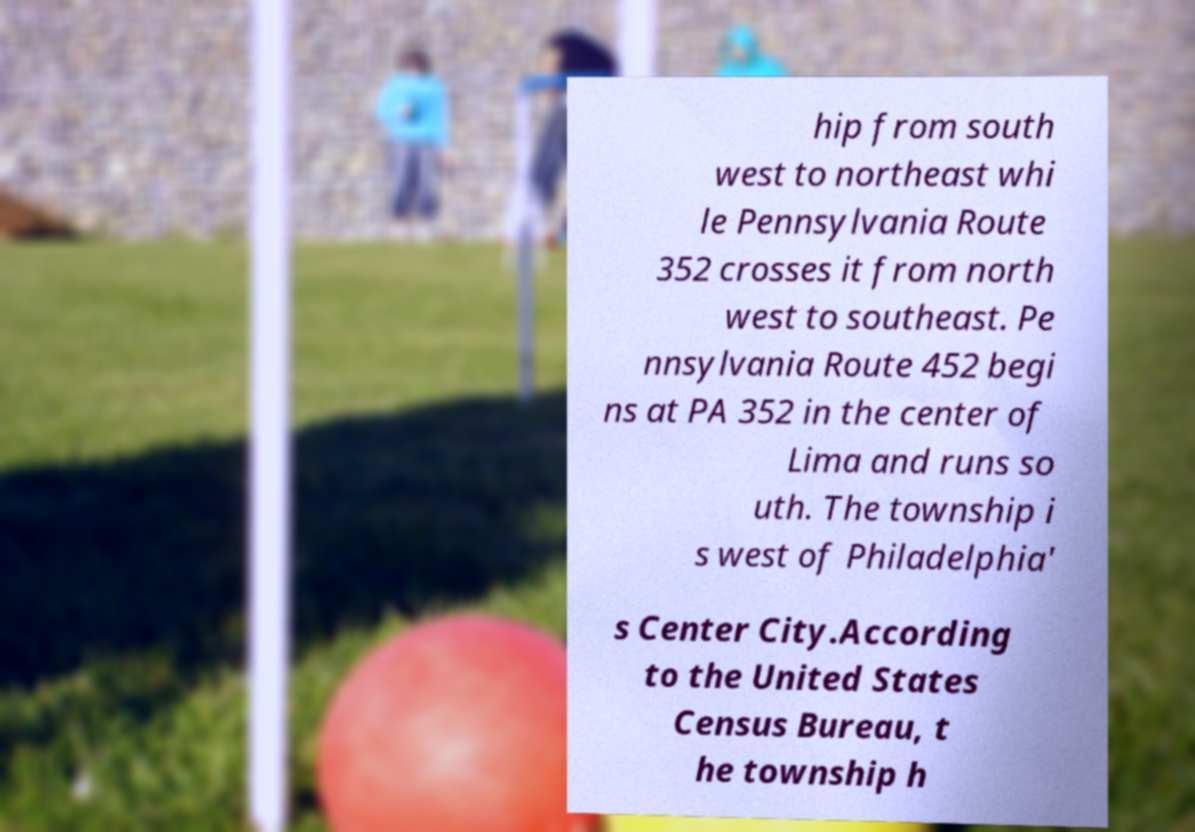I need the written content from this picture converted into text. Can you do that? hip from south west to northeast whi le Pennsylvania Route 352 crosses it from north west to southeast. Pe nnsylvania Route 452 begi ns at PA 352 in the center of Lima and runs so uth. The township i s west of Philadelphia' s Center City.According to the United States Census Bureau, t he township h 